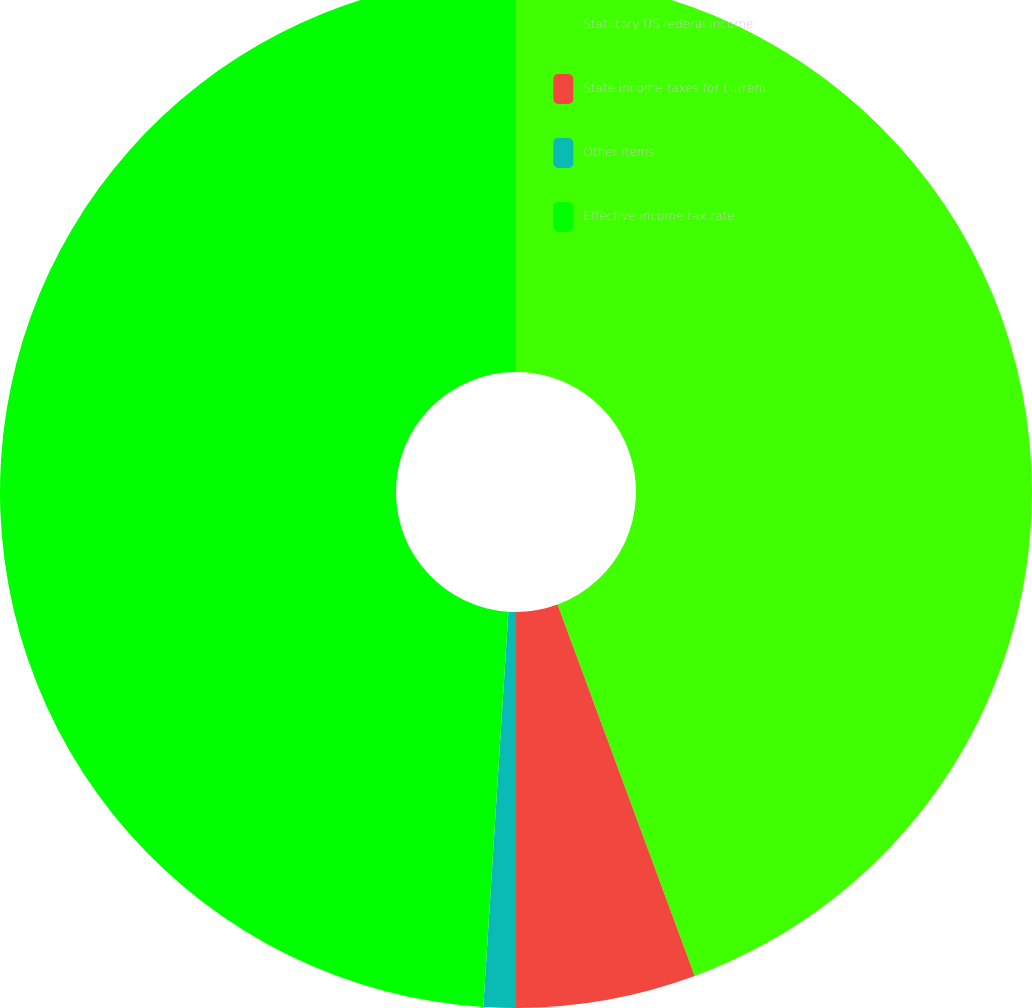Convert chart to OTSL. <chart><loc_0><loc_0><loc_500><loc_500><pie_chart><fcel>Statutory US federal income<fcel>State income taxes for current<fcel>Other items<fcel>Effective income tax rate<nl><fcel>44.37%<fcel>5.63%<fcel>1.01%<fcel>48.99%<nl></chart> 